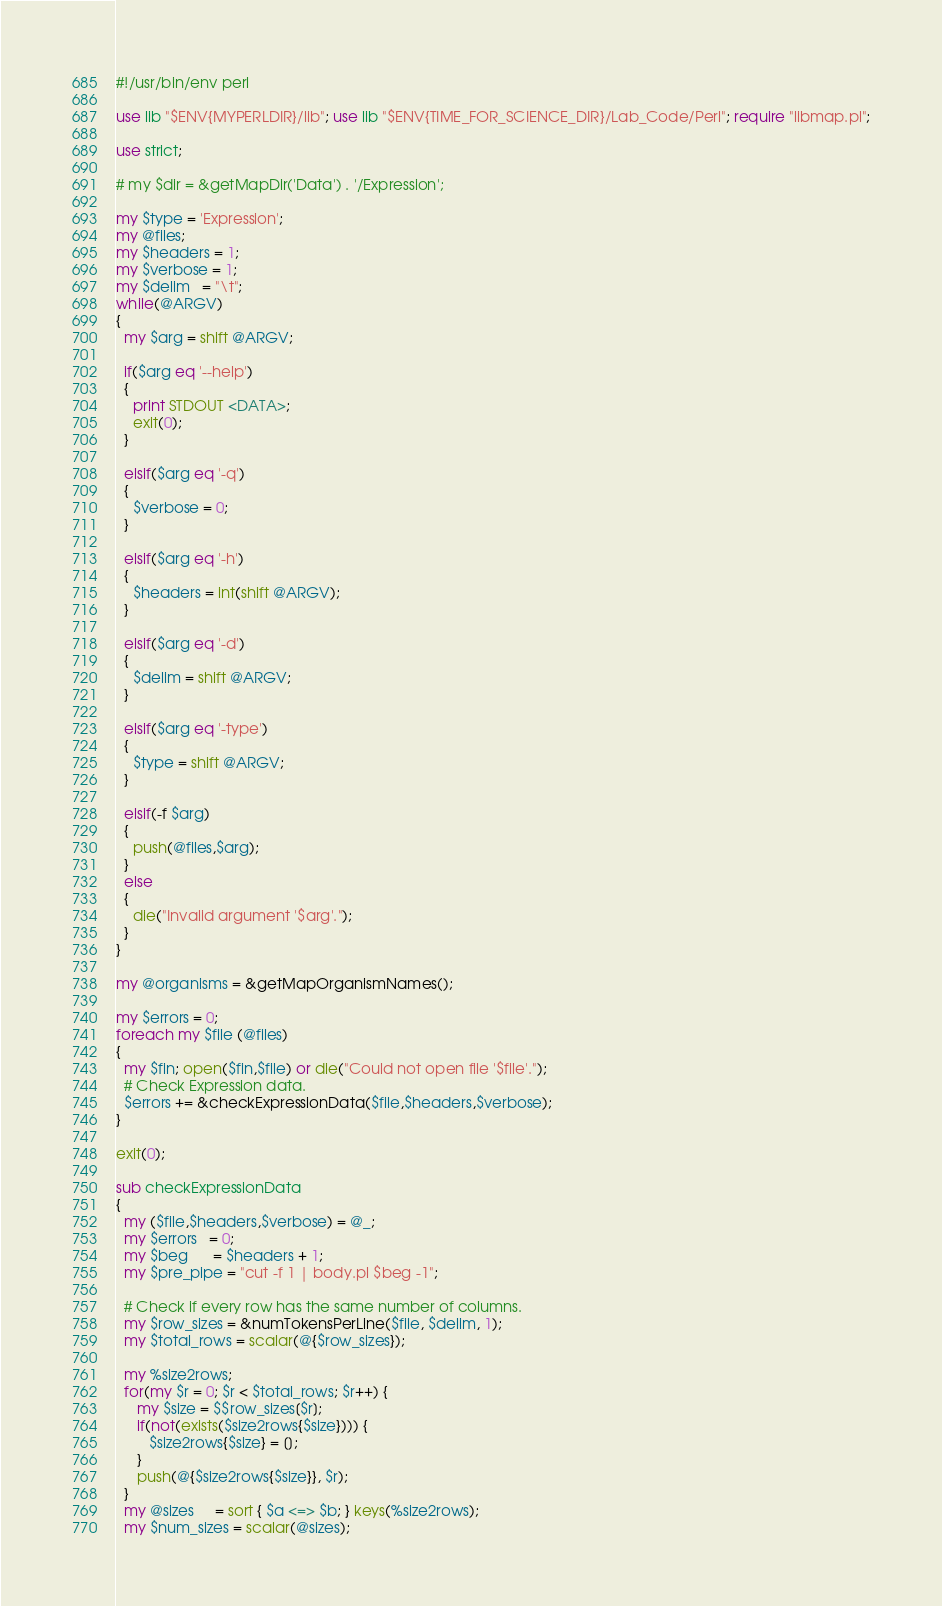Convert code to text. <code><loc_0><loc_0><loc_500><loc_500><_Perl_>#!/usr/bin/env perl

use lib "$ENV{MYPERLDIR}/lib"; use lib "$ENV{TIME_FOR_SCIENCE_DIR}/Lab_Code/Perl"; require "libmap.pl";

use strict;

# my $dir = &getMapDir('Data') . '/Expression';

my $type = 'Expression';
my @files;
my $headers = 1;
my $verbose = 1;
my $delim   = "\t";
while(@ARGV)
{
  my $arg = shift @ARGV;

  if($arg eq '--help')
  {
    print STDOUT <DATA>;
    exit(0);
  }

  elsif($arg eq '-q')
  {
    $verbose = 0;
  }

  elsif($arg eq '-h')
  {
    $headers = int(shift @ARGV);
  }

  elsif($arg eq '-d')
  {
    $delim = shift @ARGV;
  }

  elsif($arg eq '-type')
  {
    $type = shift @ARGV;
  }

  elsif(-f $arg)
  {
    push(@files,$arg);
  }
  else
  {
    die("Invalid argument '$arg'.");
  }
}

my @organisms = &getMapOrganismNames();

my $errors = 0;
foreach my $file (@files)
{
  my $fin; open($fin,$file) or die("Could not open file '$file'.");
  # Check Expression data.
  $errors += &checkExpressionData($file,$headers,$verbose);
}

exit(0);

sub checkExpressionData
{
  my ($file,$headers,$verbose) = @_;
  my $errors   = 0;
  my $beg      = $headers + 1;
  my $pre_pipe = "cut -f 1 | body.pl $beg -1";

  # Check if every row has the same number of columns.
  my $row_sizes = &numTokensPerLine($file, $delim, 1);
  my $total_rows = scalar(@{$row_sizes});

  my %size2rows;
  for(my $r = 0; $r < $total_rows; $r++) {
     my $size = $$row_sizes[$r];
     if(not(exists($size2rows{$size}))) {
        $size2rows{$size} = [];
     }
     push(@{$size2rows{$size}}, $r);
  }
  my @sizes     = sort { $a <=> $b; } keys(%size2rows);
  my $num_sizes = scalar(@sizes);
</code> 